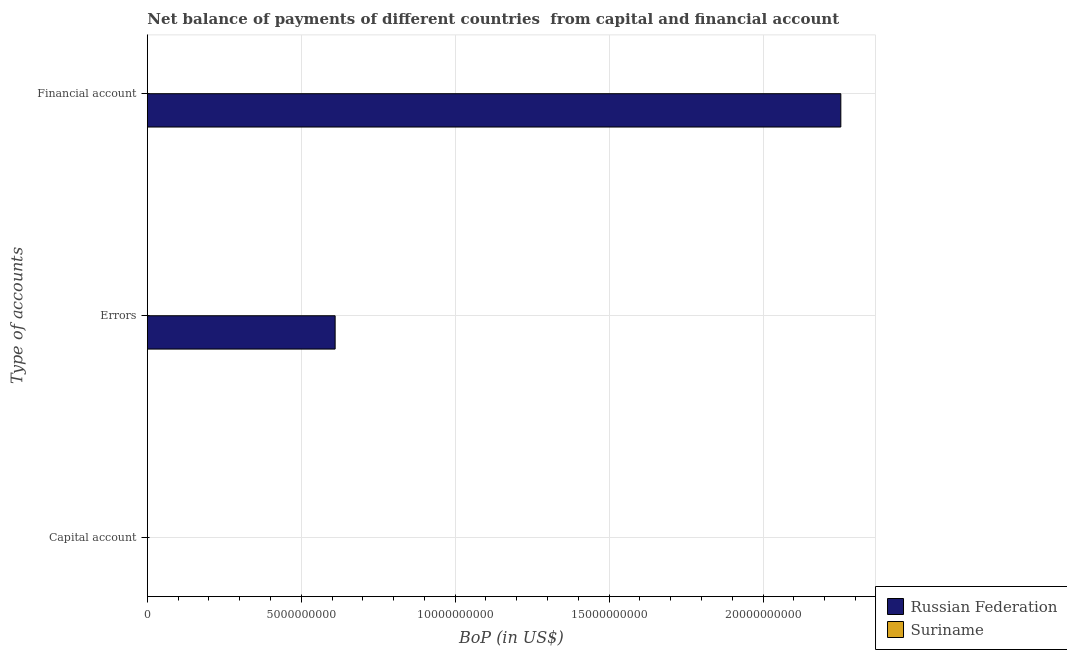Are the number of bars on each tick of the Y-axis equal?
Your answer should be very brief. No. What is the label of the 1st group of bars from the top?
Offer a very short reply. Financial account. What is the amount of errors in Suriname?
Offer a very short reply. 0. Across all countries, what is the maximum amount of financial account?
Your response must be concise. 2.25e+1. Across all countries, what is the minimum amount of financial account?
Keep it short and to the point. 0. In which country was the amount of financial account maximum?
Make the answer very short. Russian Federation. What is the difference between the amount of errors in Russian Federation and the amount of net capital account in Suriname?
Provide a short and direct response. 6.10e+09. What is the average amount of financial account per country?
Offer a terse response. 1.13e+1. What is the difference between the amount of errors and amount of financial account in Russian Federation?
Ensure brevity in your answer.  -1.64e+1. In how many countries, is the amount of net capital account greater than 12000000000 US$?
Ensure brevity in your answer.  0. What is the difference between the highest and the lowest amount of financial account?
Offer a terse response. 2.25e+1. Are the values on the major ticks of X-axis written in scientific E-notation?
Your answer should be compact. No. Does the graph contain grids?
Offer a terse response. Yes. Where does the legend appear in the graph?
Your answer should be very brief. Bottom right. What is the title of the graph?
Ensure brevity in your answer.  Net balance of payments of different countries  from capital and financial account. What is the label or title of the X-axis?
Your answer should be compact. BoP (in US$). What is the label or title of the Y-axis?
Your response must be concise. Type of accounts. What is the BoP (in US$) in Russian Federation in Capital account?
Provide a short and direct response. 0. What is the BoP (in US$) of Suriname in Capital account?
Your answer should be very brief. 0. What is the BoP (in US$) in Russian Federation in Errors?
Your answer should be compact. 6.10e+09. What is the BoP (in US$) of Suriname in Errors?
Your answer should be very brief. 0. What is the BoP (in US$) in Russian Federation in Financial account?
Keep it short and to the point. 2.25e+1. Across all Type of accounts, what is the maximum BoP (in US$) of Russian Federation?
Offer a terse response. 2.25e+1. Across all Type of accounts, what is the minimum BoP (in US$) of Russian Federation?
Your answer should be very brief. 0. What is the total BoP (in US$) in Russian Federation in the graph?
Give a very brief answer. 2.86e+1. What is the difference between the BoP (in US$) of Russian Federation in Errors and that in Financial account?
Provide a succinct answer. -1.64e+1. What is the average BoP (in US$) of Russian Federation per Type of accounts?
Your answer should be very brief. 9.54e+09. What is the ratio of the BoP (in US$) of Russian Federation in Errors to that in Financial account?
Your answer should be very brief. 0.27. What is the difference between the highest and the lowest BoP (in US$) in Russian Federation?
Make the answer very short. 2.25e+1. 